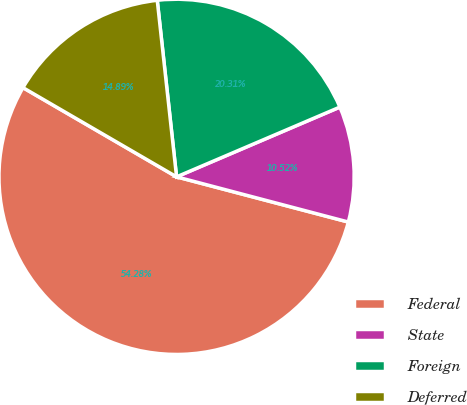Convert chart. <chart><loc_0><loc_0><loc_500><loc_500><pie_chart><fcel>Federal<fcel>State<fcel>Foreign<fcel>Deferred<nl><fcel>54.28%<fcel>10.52%<fcel>20.31%<fcel>14.89%<nl></chart> 